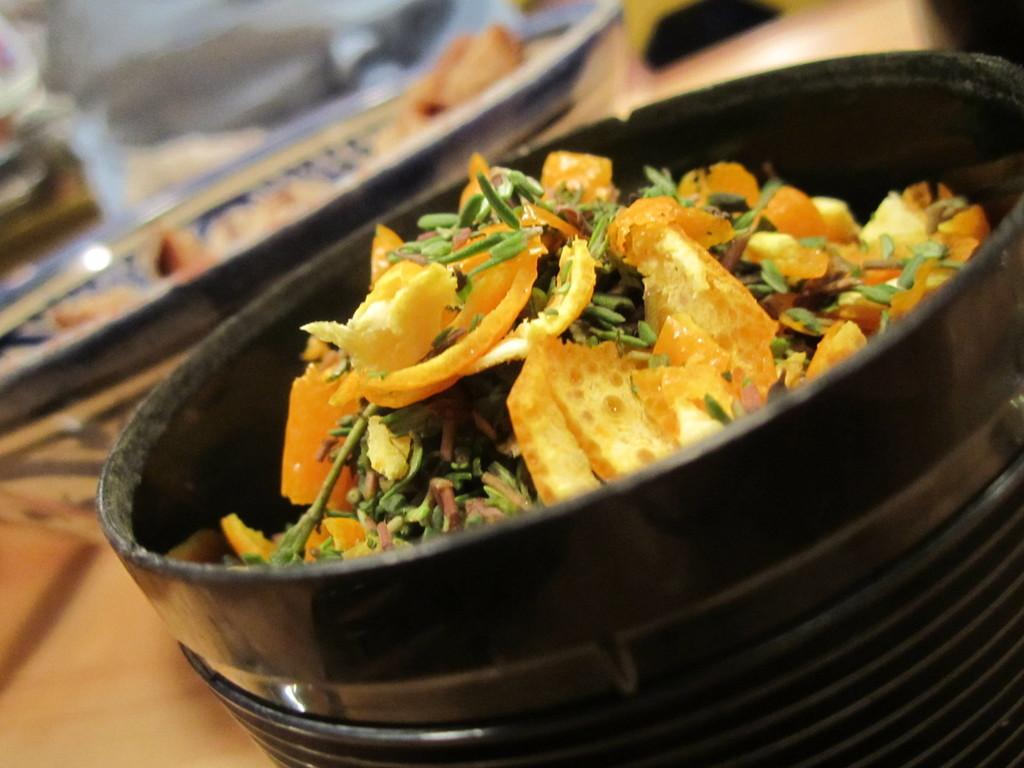What object is present in the image that can hold food? There is a bowl in the image that can hold food. What is the color of the bowl? The bowl is black in color. What is placed in the center of the bowl? There is a plate in the middle of the bowl. What is on the plate? The plate contains some eatables. Can you see any grass growing on the plate in the image? No, there is no grass present in the image. The plate contains eatables, not grass. 